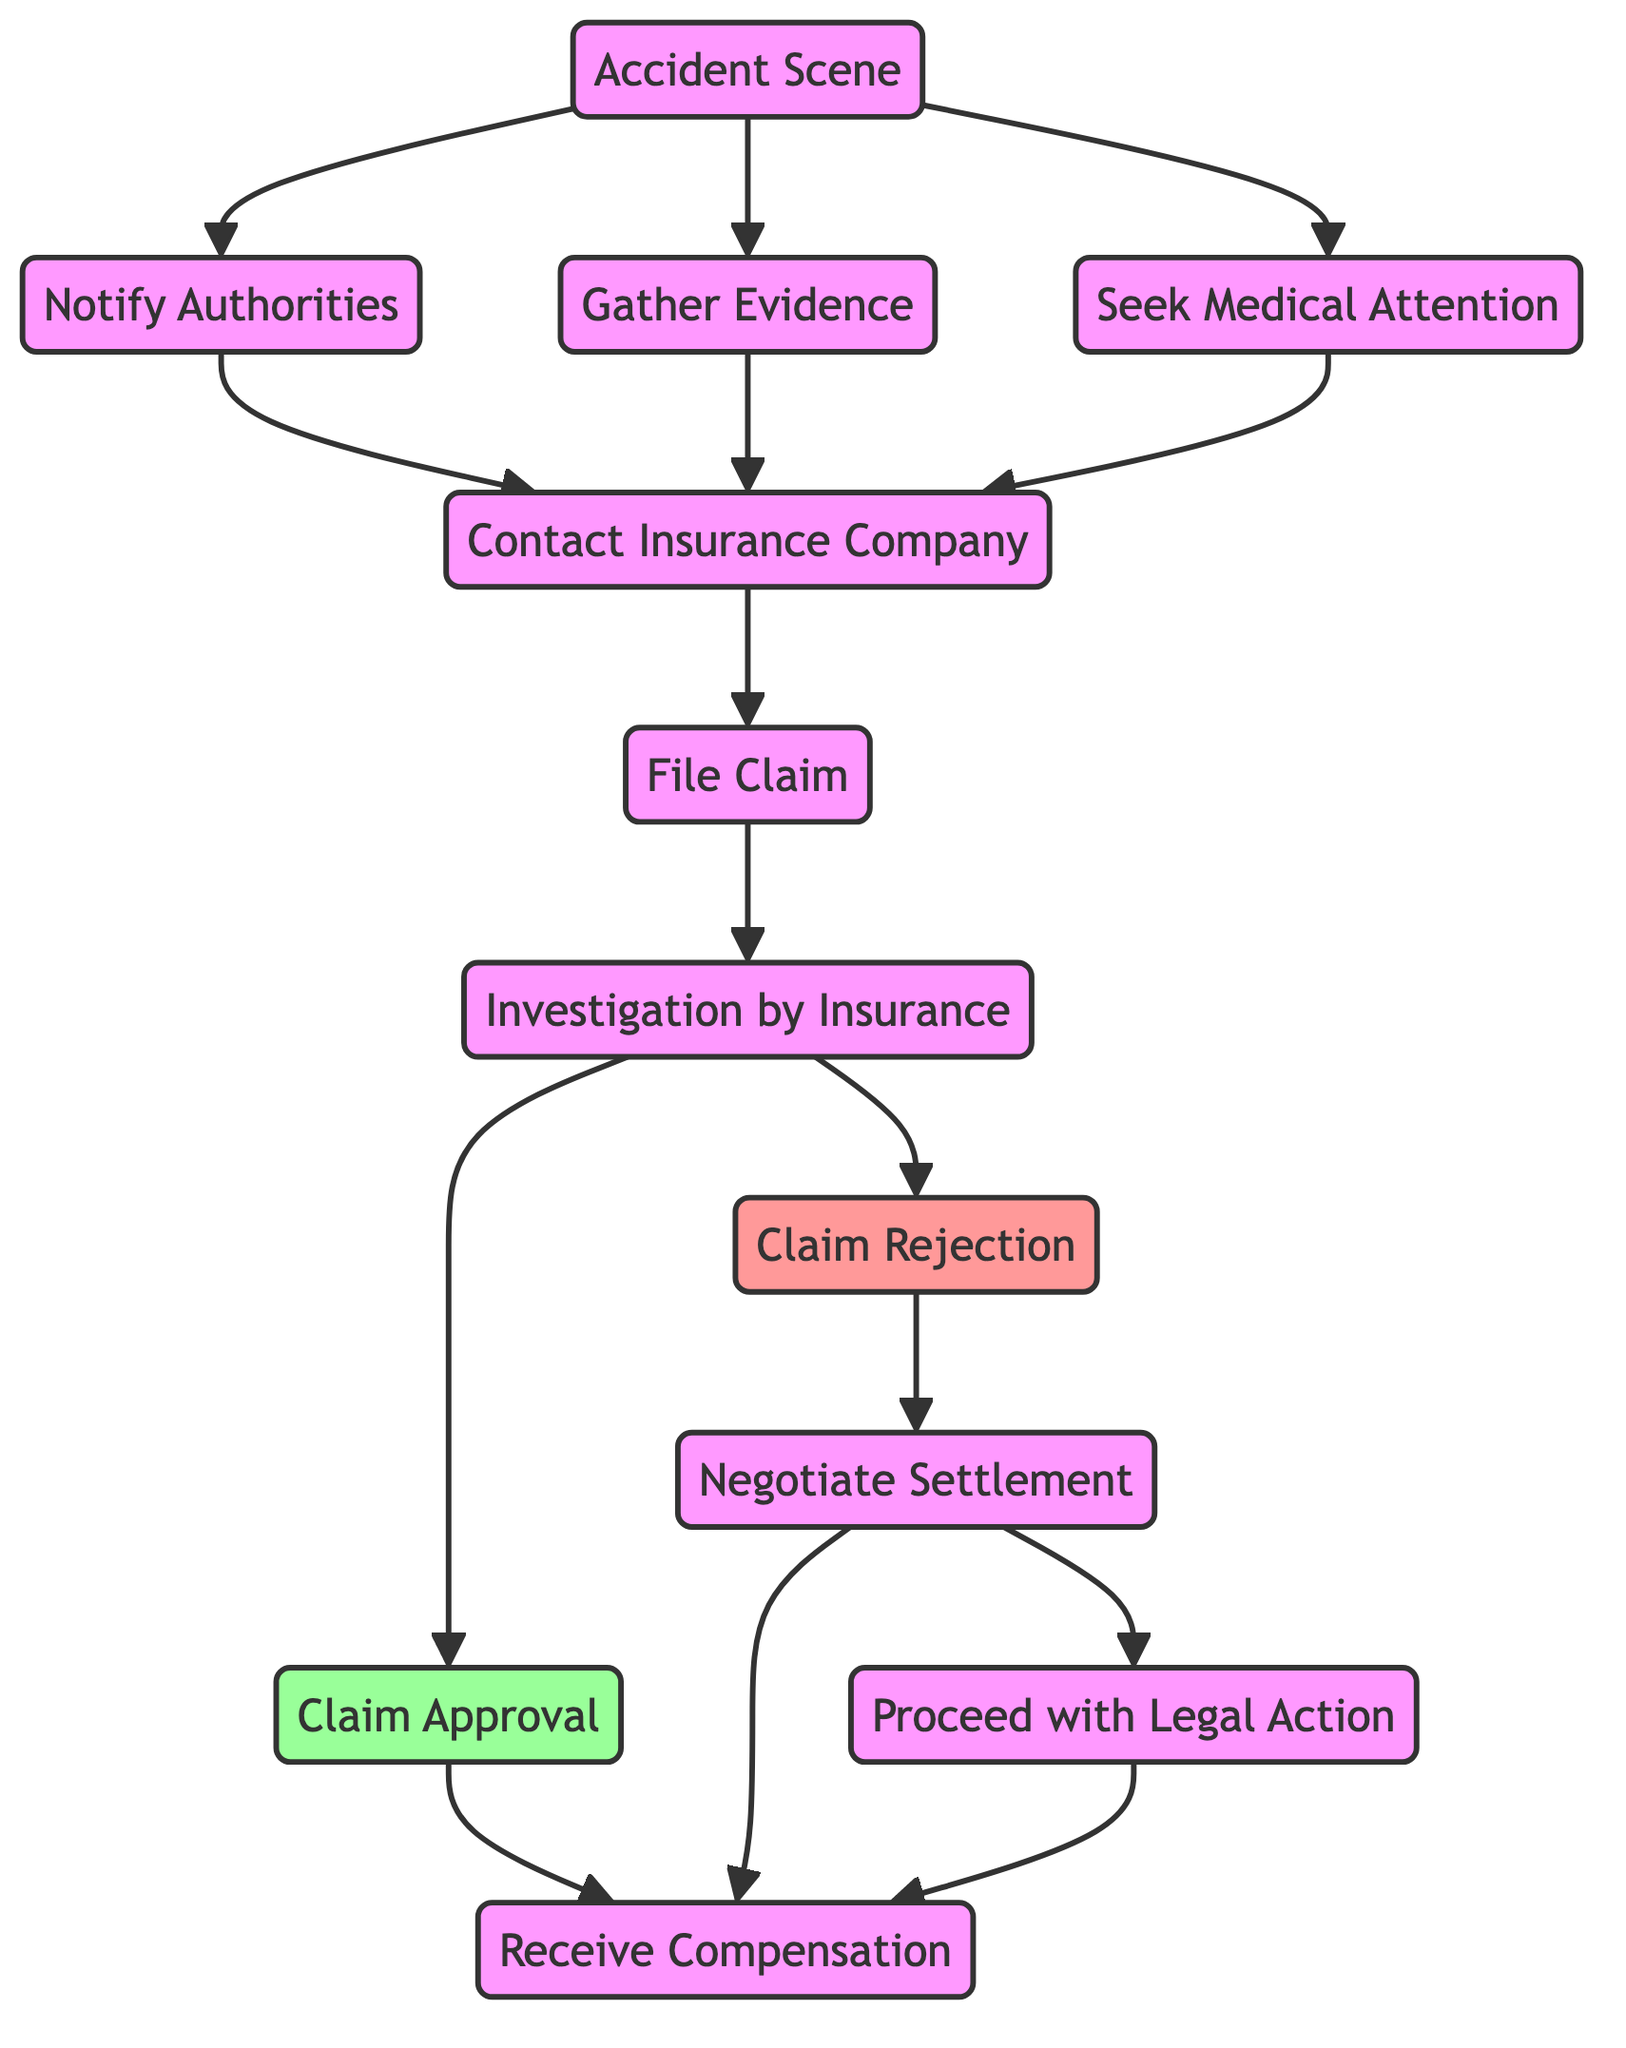What is the first step after the Accident Scene? The first step after the Accident Scene is to notify the authorities, as it is a direct transition from the Accident Scene to Notify Authorities in the directed graph.
Answer: Notify Authorities How many nodes are in the diagram? Counting the unique elements that represent steps or processes in the directed graph, I find there are a total of 12 nodes present.
Answer: 12 What are the two options after Claim Rejection? After Claim Rejection, the two options are to negotiate a settlement or proceed with legal action, indicated by the edges leading from Claim Rejection to Negotiate Settlement and Proceed with Legal Action.
Answer: Negotiate Settlement, Proceed with Legal Action Which node leads to Receive Compensation directly? The node leading to Receive Compensation directly is Claim Approval, as it has a direct edge connecting to the Receive Compensation node.
Answer: Claim Approval What comes after Investigation if the claim is rejected? If the claim is rejected, the next step is to enter into Negotiation for Settlement, indicated by the edge running from Investigation to Claim Rejection and then to Negotiate Settlement.
Answer: Negotiate Settlement What step follows after filing a claim? The step that follows after filing a claim is the Investigation, as shown by the directed edge from File Claim to Investigation in the diagram.
Answer: Investigation Is Seeking Medical Attention necessary before contacting the insurance? Yes, Seeking Medical Attention is one of the three parallel steps that can occur before contacting the insurance, as represented by the edges from both Seeking Medical Attention to Contact Insurance.
Answer: Yes What are the possible outcomes after Claim Approval? The possible outcome after Claim Approval is to receive compensation, which is a direct flow from Claim Approval to Receive Compensation in the graph.
Answer: Receive Compensation What is the first action to take at the Accident Scene? The first action to take at the Accident Scene includes notifying authorities, gathering evidence, and seeking medical attention, showing simultaneous paths directed from Accident Scene.
Answer: Notify Authorities, Gather Evidence, Seek Medical Attention 